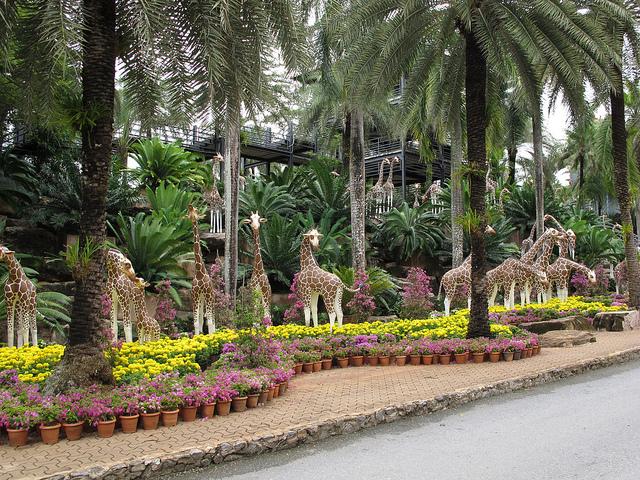What type of trees are these?
Short answer required. Palm. Are the flowers beautiful?
Keep it brief. Yes. Are there any weeds in the scene?
Short answer required. No. Are there more than 4 giraffes in the picture?
Short answer required. Yes. 